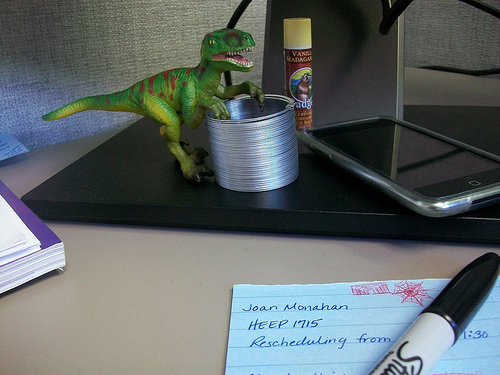<image>
Can you confirm if the dinosaur is to the left of the cell phone? Yes. From this viewpoint, the dinosaur is positioned to the left side relative to the cell phone. Is there a mobilephone in the gum? No. The mobilephone is not contained within the gum. These objects have a different spatial relationship. 